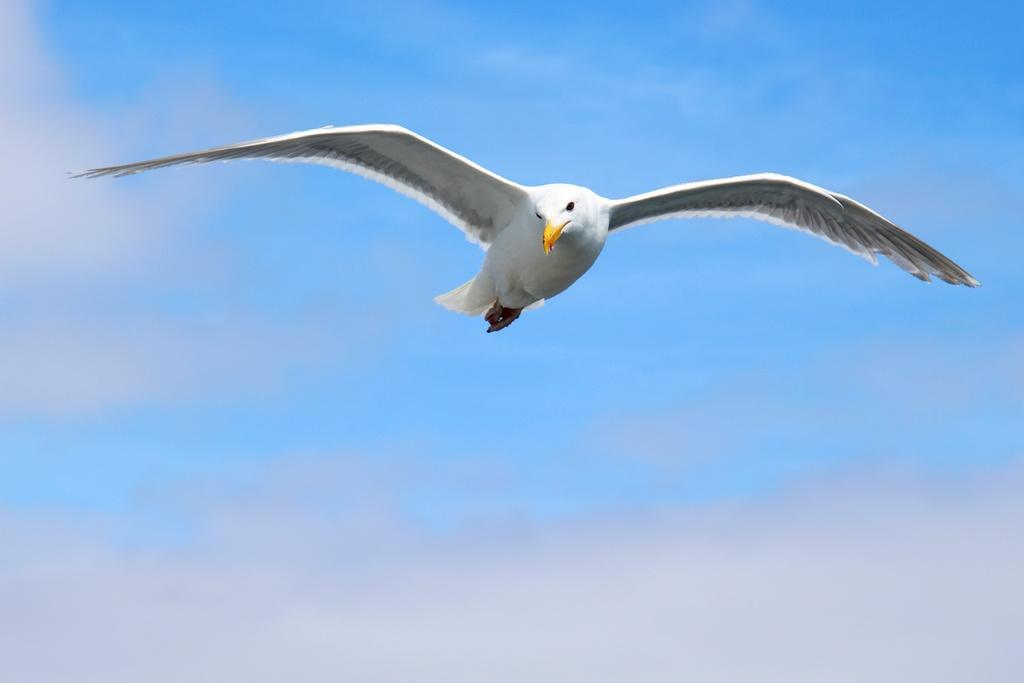What is the main subject of the image? The main subject of the image is a bird flying. Where is the bird located in the image? The bird is in the sky. What can be seen in the background of the image? The sky is visible in the background of the image. What type of lipstick is the bird wearing in the image? There is no lipstick or any indication of makeup on the bird in the image. 